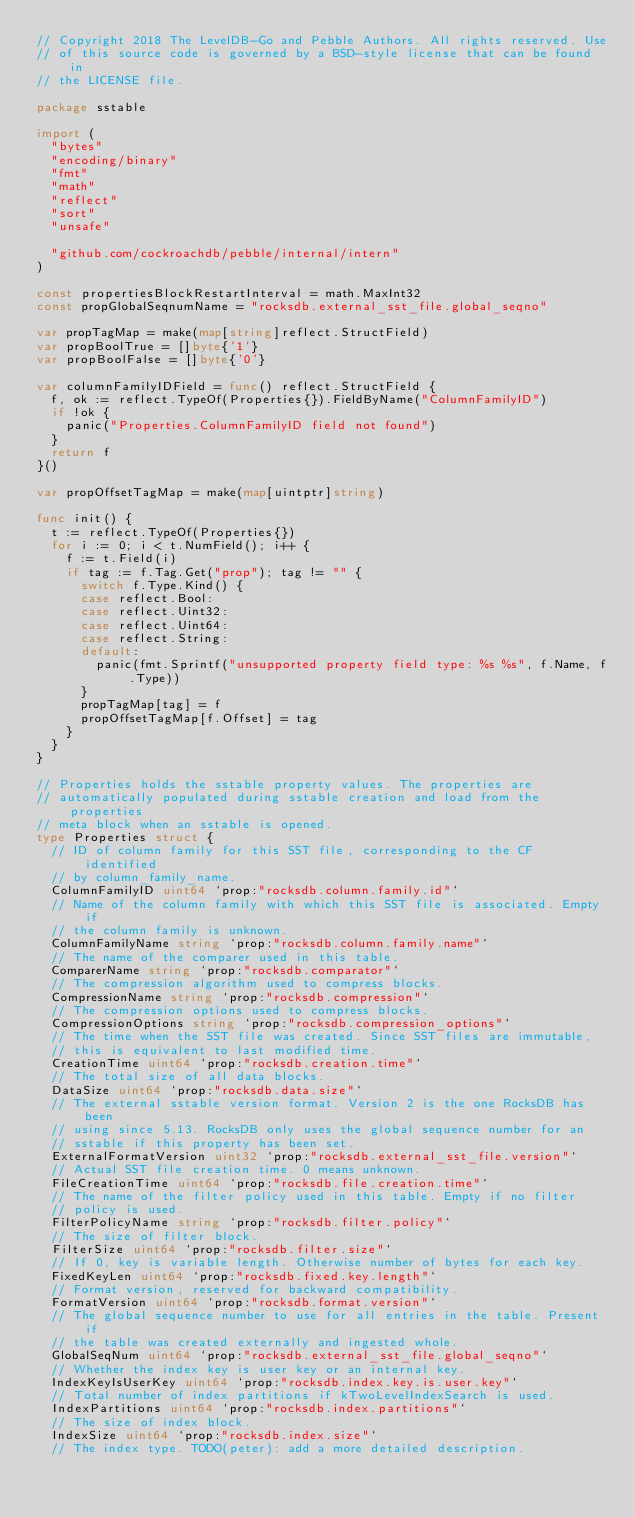<code> <loc_0><loc_0><loc_500><loc_500><_Go_>// Copyright 2018 The LevelDB-Go and Pebble Authors. All rights reserved. Use
// of this source code is governed by a BSD-style license that can be found in
// the LICENSE file.

package sstable

import (
	"bytes"
	"encoding/binary"
	"fmt"
	"math"
	"reflect"
	"sort"
	"unsafe"

	"github.com/cockroachdb/pebble/internal/intern"
)

const propertiesBlockRestartInterval = math.MaxInt32
const propGlobalSeqnumName = "rocksdb.external_sst_file.global_seqno"

var propTagMap = make(map[string]reflect.StructField)
var propBoolTrue = []byte{'1'}
var propBoolFalse = []byte{'0'}

var columnFamilyIDField = func() reflect.StructField {
	f, ok := reflect.TypeOf(Properties{}).FieldByName("ColumnFamilyID")
	if !ok {
		panic("Properties.ColumnFamilyID field not found")
	}
	return f
}()

var propOffsetTagMap = make(map[uintptr]string)

func init() {
	t := reflect.TypeOf(Properties{})
	for i := 0; i < t.NumField(); i++ {
		f := t.Field(i)
		if tag := f.Tag.Get("prop"); tag != "" {
			switch f.Type.Kind() {
			case reflect.Bool:
			case reflect.Uint32:
			case reflect.Uint64:
			case reflect.String:
			default:
				panic(fmt.Sprintf("unsupported property field type: %s %s", f.Name, f.Type))
			}
			propTagMap[tag] = f
			propOffsetTagMap[f.Offset] = tag
		}
	}
}

// Properties holds the sstable property values. The properties are
// automatically populated during sstable creation and load from the properties
// meta block when an sstable is opened.
type Properties struct {
	// ID of column family for this SST file, corresponding to the CF identified
	// by column_family_name.
	ColumnFamilyID uint64 `prop:"rocksdb.column.family.id"`
	// Name of the column family with which this SST file is associated. Empty if
	// the column family is unknown.
	ColumnFamilyName string `prop:"rocksdb.column.family.name"`
	// The name of the comparer used in this table.
	ComparerName string `prop:"rocksdb.comparator"`
	// The compression algorithm used to compress blocks.
	CompressionName string `prop:"rocksdb.compression"`
	// The compression options used to compress blocks.
	CompressionOptions string `prop:"rocksdb.compression_options"`
	// The time when the SST file was created. Since SST files are immutable,
	// this is equivalent to last modified time.
	CreationTime uint64 `prop:"rocksdb.creation.time"`
	// The total size of all data blocks.
	DataSize uint64 `prop:"rocksdb.data.size"`
	// The external sstable version format. Version 2 is the one RocksDB has been
	// using since 5.13. RocksDB only uses the global sequence number for an
	// sstable if this property has been set.
	ExternalFormatVersion uint32 `prop:"rocksdb.external_sst_file.version"`
	// Actual SST file creation time. 0 means unknown.
	FileCreationTime uint64 `prop:"rocksdb.file.creation.time"`
	// The name of the filter policy used in this table. Empty if no filter
	// policy is used.
	FilterPolicyName string `prop:"rocksdb.filter.policy"`
	// The size of filter block.
	FilterSize uint64 `prop:"rocksdb.filter.size"`
	// If 0, key is variable length. Otherwise number of bytes for each key.
	FixedKeyLen uint64 `prop:"rocksdb.fixed.key.length"`
	// Format version, reserved for backward compatibility.
	FormatVersion uint64 `prop:"rocksdb.format.version"`
	// The global sequence number to use for all entries in the table. Present if
	// the table was created externally and ingested whole.
	GlobalSeqNum uint64 `prop:"rocksdb.external_sst_file.global_seqno"`
	// Whether the index key is user key or an internal key.
	IndexKeyIsUserKey uint64 `prop:"rocksdb.index.key.is.user.key"`
	// Total number of index partitions if kTwoLevelIndexSearch is used.
	IndexPartitions uint64 `prop:"rocksdb.index.partitions"`
	// The size of index block.
	IndexSize uint64 `prop:"rocksdb.index.size"`
	// The index type. TODO(peter): add a more detailed description.</code> 